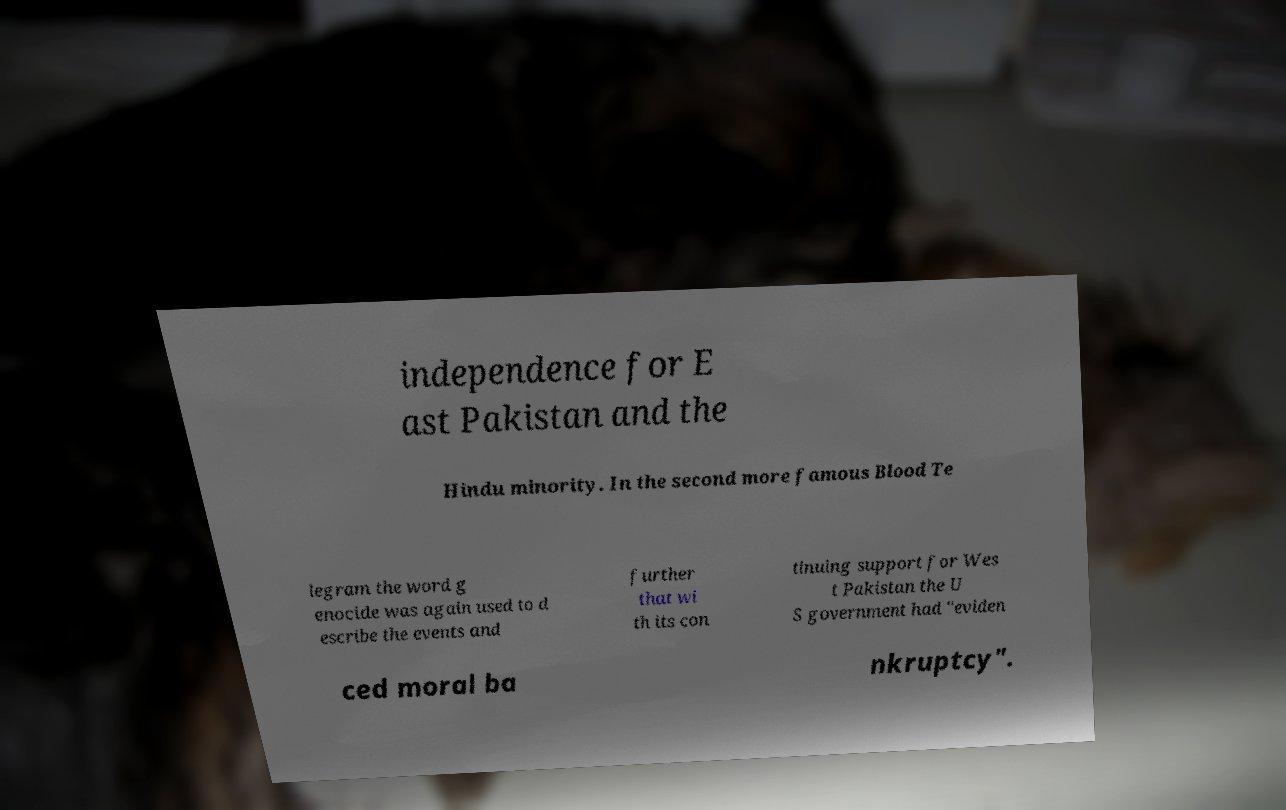What messages or text are displayed in this image? I need them in a readable, typed format. independence for E ast Pakistan and the Hindu minority. In the second more famous Blood Te legram the word g enocide was again used to d escribe the events and further that wi th its con tinuing support for Wes t Pakistan the U S government had "eviden ced moral ba nkruptcy". 